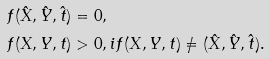Convert formula to latex. <formula><loc_0><loc_0><loc_500><loc_500>f ( \hat { X } , \hat { Y } , \hat { t } ) & = 0 , \\ f ( X , Y , t ) & > 0 , i f ( X , Y , t ) \neq ( \hat { X } , \hat { Y } , \hat { t } ) .</formula> 